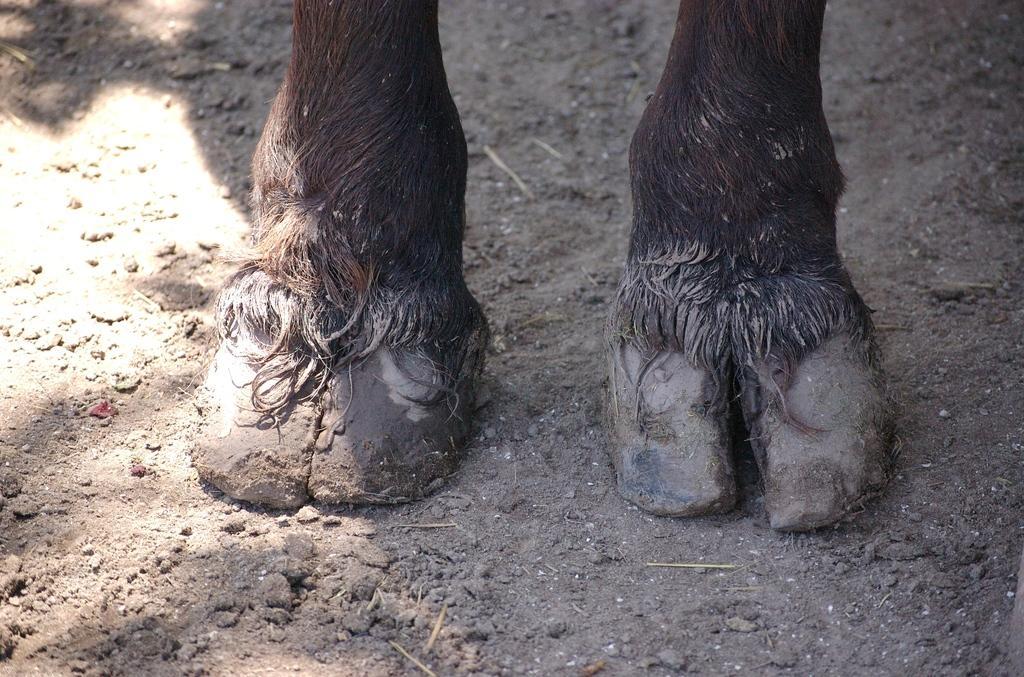Could you give a brief overview of what you see in this image? In this image we can see that there are legs of an animal on the ground. On the ground there is sand. 